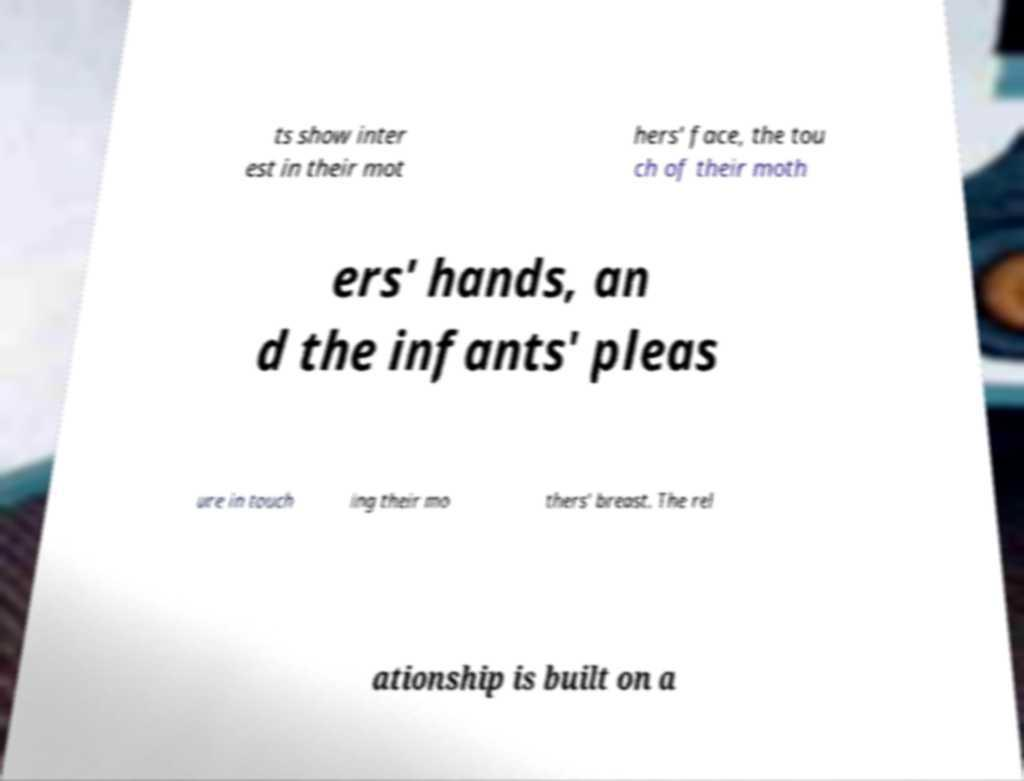What messages or text are displayed in this image? I need them in a readable, typed format. ts show inter est in their mot hers' face, the tou ch of their moth ers' hands, an d the infants' pleas ure in touch ing their mo thers' breast. The rel ationship is built on a 